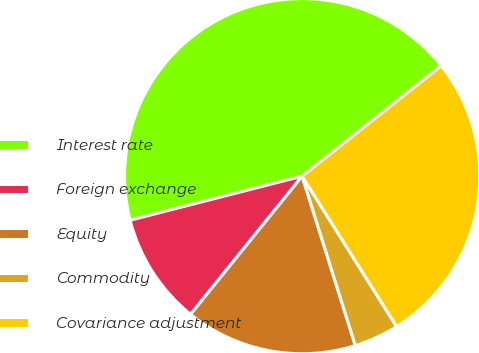<chart> <loc_0><loc_0><loc_500><loc_500><pie_chart><fcel>Interest rate<fcel>Foreign exchange<fcel>Equity<fcel>Commodity<fcel>Covariance adjustment<nl><fcel>43.31%<fcel>10.2%<fcel>15.65%<fcel>4.08%<fcel>26.76%<nl></chart> 